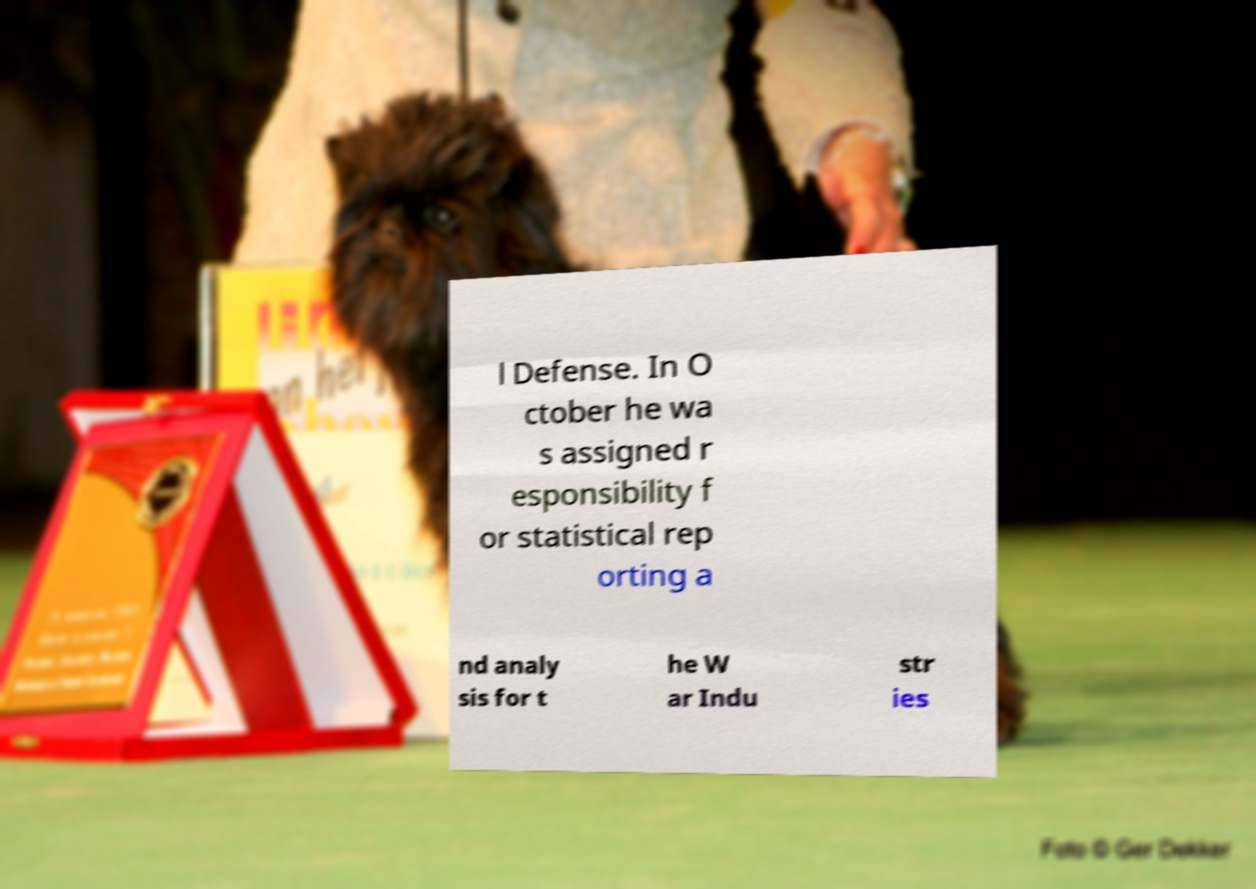Please read and relay the text visible in this image. What does it say? l Defense. In O ctober he wa s assigned r esponsibility f or statistical rep orting a nd analy sis for t he W ar Indu str ies 